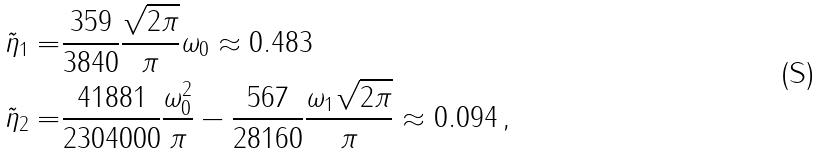<formula> <loc_0><loc_0><loc_500><loc_500>\tilde { \eta } _ { 1 } = & \frac { 3 5 9 } { 3 8 4 0 } \frac { \sqrt { 2 \pi } } { \pi } \omega _ { 0 } \approx 0 . 4 8 3 \\ \tilde { \eta } _ { 2 } = & \frac { 4 1 8 8 1 } { 2 3 0 4 0 0 0 } \frac { \omega _ { 0 } ^ { 2 } } { \pi } - \frac { 5 6 7 } { 2 8 1 6 0 } \frac { \omega _ { 1 } \sqrt { 2 \pi } } { \pi } \approx 0 . 0 9 4 \, ,</formula> 